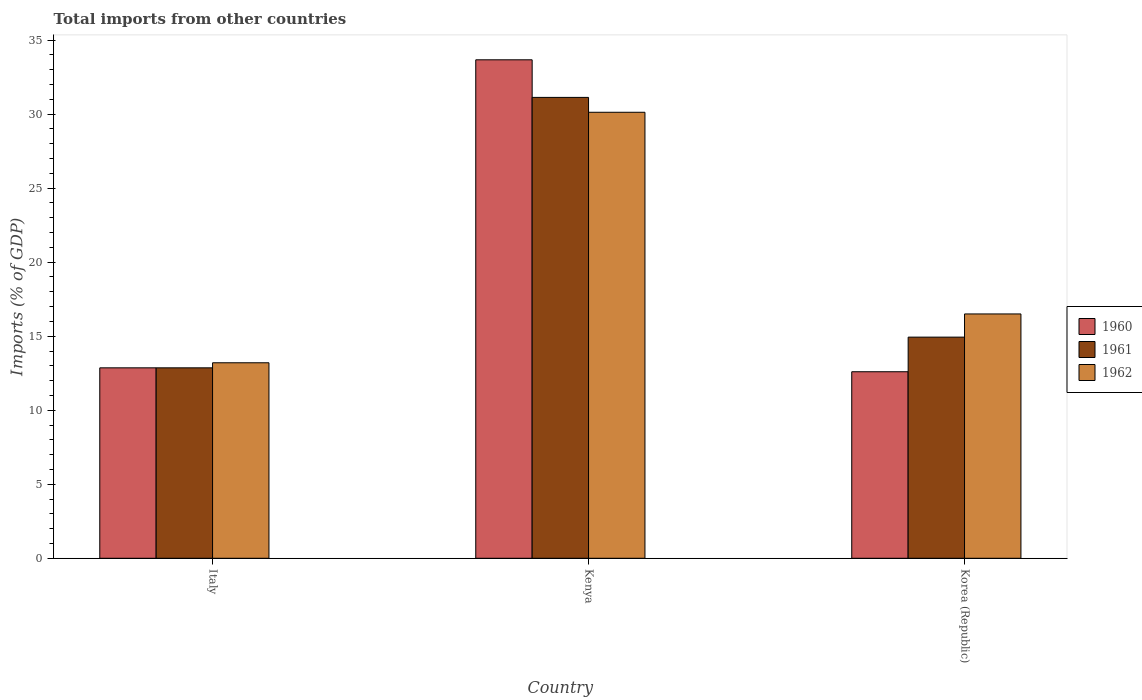How many groups of bars are there?
Give a very brief answer. 3. Are the number of bars on each tick of the X-axis equal?
Ensure brevity in your answer.  Yes. How many bars are there on the 1st tick from the right?
Provide a short and direct response. 3. What is the label of the 2nd group of bars from the left?
Give a very brief answer. Kenya. What is the total imports in 1960 in Italy?
Keep it short and to the point. 12.86. Across all countries, what is the maximum total imports in 1962?
Your answer should be compact. 30.13. Across all countries, what is the minimum total imports in 1961?
Keep it short and to the point. 12.86. In which country was the total imports in 1960 maximum?
Give a very brief answer. Kenya. In which country was the total imports in 1960 minimum?
Your response must be concise. Korea (Republic). What is the total total imports in 1961 in the graph?
Offer a terse response. 58.93. What is the difference between the total imports in 1961 in Italy and that in Korea (Republic)?
Offer a terse response. -2.07. What is the difference between the total imports in 1962 in Kenya and the total imports in 1960 in Italy?
Make the answer very short. 17.26. What is the average total imports in 1962 per country?
Provide a short and direct response. 19.94. What is the difference between the total imports of/in 1961 and total imports of/in 1960 in Kenya?
Keep it short and to the point. -2.54. In how many countries, is the total imports in 1962 greater than 3 %?
Provide a short and direct response. 3. What is the ratio of the total imports in 1961 in Italy to that in Korea (Republic)?
Provide a short and direct response. 0.86. Is the total imports in 1962 in Italy less than that in Korea (Republic)?
Your response must be concise. Yes. What is the difference between the highest and the second highest total imports in 1962?
Provide a succinct answer. 3.3. What is the difference between the highest and the lowest total imports in 1961?
Make the answer very short. 18.27. Is it the case that in every country, the sum of the total imports in 1962 and total imports in 1961 is greater than the total imports in 1960?
Keep it short and to the point. Yes. How many bars are there?
Offer a very short reply. 9. How many countries are there in the graph?
Your response must be concise. 3. What is the difference between two consecutive major ticks on the Y-axis?
Ensure brevity in your answer.  5. Are the values on the major ticks of Y-axis written in scientific E-notation?
Offer a terse response. No. Does the graph contain grids?
Keep it short and to the point. No. Where does the legend appear in the graph?
Your answer should be compact. Center right. How are the legend labels stacked?
Keep it short and to the point. Vertical. What is the title of the graph?
Offer a terse response. Total imports from other countries. Does "1996" appear as one of the legend labels in the graph?
Make the answer very short. No. What is the label or title of the Y-axis?
Provide a succinct answer. Imports (% of GDP). What is the Imports (% of GDP) of 1960 in Italy?
Offer a very short reply. 12.86. What is the Imports (% of GDP) in 1961 in Italy?
Your response must be concise. 12.86. What is the Imports (% of GDP) in 1962 in Italy?
Give a very brief answer. 13.2. What is the Imports (% of GDP) of 1960 in Kenya?
Keep it short and to the point. 33.67. What is the Imports (% of GDP) of 1961 in Kenya?
Provide a short and direct response. 31.13. What is the Imports (% of GDP) in 1962 in Kenya?
Ensure brevity in your answer.  30.13. What is the Imports (% of GDP) of 1960 in Korea (Republic)?
Make the answer very short. 12.6. What is the Imports (% of GDP) in 1961 in Korea (Republic)?
Keep it short and to the point. 14.94. What is the Imports (% of GDP) of 1962 in Korea (Republic)?
Your answer should be compact. 16.5. Across all countries, what is the maximum Imports (% of GDP) of 1960?
Ensure brevity in your answer.  33.67. Across all countries, what is the maximum Imports (% of GDP) of 1961?
Offer a very short reply. 31.13. Across all countries, what is the maximum Imports (% of GDP) in 1962?
Your answer should be compact. 30.13. Across all countries, what is the minimum Imports (% of GDP) of 1960?
Keep it short and to the point. 12.6. Across all countries, what is the minimum Imports (% of GDP) of 1961?
Ensure brevity in your answer.  12.86. Across all countries, what is the minimum Imports (% of GDP) in 1962?
Give a very brief answer. 13.2. What is the total Imports (% of GDP) of 1960 in the graph?
Provide a short and direct response. 59.13. What is the total Imports (% of GDP) of 1961 in the graph?
Provide a short and direct response. 58.93. What is the total Imports (% of GDP) of 1962 in the graph?
Your answer should be compact. 59.83. What is the difference between the Imports (% of GDP) of 1960 in Italy and that in Kenya?
Offer a very short reply. -20.81. What is the difference between the Imports (% of GDP) in 1961 in Italy and that in Kenya?
Your answer should be compact. -18.27. What is the difference between the Imports (% of GDP) of 1962 in Italy and that in Kenya?
Ensure brevity in your answer.  -16.92. What is the difference between the Imports (% of GDP) in 1960 in Italy and that in Korea (Republic)?
Provide a succinct answer. 0.26. What is the difference between the Imports (% of GDP) of 1961 in Italy and that in Korea (Republic)?
Ensure brevity in your answer.  -2.07. What is the difference between the Imports (% of GDP) of 1962 in Italy and that in Korea (Republic)?
Give a very brief answer. -3.3. What is the difference between the Imports (% of GDP) of 1960 in Kenya and that in Korea (Republic)?
Ensure brevity in your answer.  21.07. What is the difference between the Imports (% of GDP) in 1961 in Kenya and that in Korea (Republic)?
Your response must be concise. 16.19. What is the difference between the Imports (% of GDP) of 1962 in Kenya and that in Korea (Republic)?
Provide a short and direct response. 13.62. What is the difference between the Imports (% of GDP) in 1960 in Italy and the Imports (% of GDP) in 1961 in Kenya?
Offer a terse response. -18.27. What is the difference between the Imports (% of GDP) in 1960 in Italy and the Imports (% of GDP) in 1962 in Kenya?
Your answer should be very brief. -17.26. What is the difference between the Imports (% of GDP) of 1961 in Italy and the Imports (% of GDP) of 1962 in Kenya?
Your response must be concise. -17.26. What is the difference between the Imports (% of GDP) of 1960 in Italy and the Imports (% of GDP) of 1961 in Korea (Republic)?
Keep it short and to the point. -2.07. What is the difference between the Imports (% of GDP) of 1960 in Italy and the Imports (% of GDP) of 1962 in Korea (Republic)?
Your response must be concise. -3.64. What is the difference between the Imports (% of GDP) in 1961 in Italy and the Imports (% of GDP) in 1962 in Korea (Republic)?
Provide a succinct answer. -3.64. What is the difference between the Imports (% of GDP) of 1960 in Kenya and the Imports (% of GDP) of 1961 in Korea (Republic)?
Your response must be concise. 18.73. What is the difference between the Imports (% of GDP) in 1960 in Kenya and the Imports (% of GDP) in 1962 in Korea (Republic)?
Keep it short and to the point. 17.17. What is the difference between the Imports (% of GDP) in 1961 in Kenya and the Imports (% of GDP) in 1962 in Korea (Republic)?
Ensure brevity in your answer.  14.63. What is the average Imports (% of GDP) of 1960 per country?
Your response must be concise. 19.71. What is the average Imports (% of GDP) in 1961 per country?
Ensure brevity in your answer.  19.64. What is the average Imports (% of GDP) of 1962 per country?
Offer a very short reply. 19.94. What is the difference between the Imports (% of GDP) in 1960 and Imports (% of GDP) in 1962 in Italy?
Your answer should be compact. -0.34. What is the difference between the Imports (% of GDP) in 1961 and Imports (% of GDP) in 1962 in Italy?
Offer a terse response. -0.34. What is the difference between the Imports (% of GDP) in 1960 and Imports (% of GDP) in 1961 in Kenya?
Keep it short and to the point. 2.54. What is the difference between the Imports (% of GDP) of 1960 and Imports (% of GDP) of 1962 in Kenya?
Your response must be concise. 3.54. What is the difference between the Imports (% of GDP) in 1961 and Imports (% of GDP) in 1962 in Kenya?
Make the answer very short. 1. What is the difference between the Imports (% of GDP) of 1960 and Imports (% of GDP) of 1961 in Korea (Republic)?
Offer a terse response. -2.34. What is the difference between the Imports (% of GDP) of 1960 and Imports (% of GDP) of 1962 in Korea (Republic)?
Offer a terse response. -3.9. What is the difference between the Imports (% of GDP) of 1961 and Imports (% of GDP) of 1962 in Korea (Republic)?
Your response must be concise. -1.57. What is the ratio of the Imports (% of GDP) in 1960 in Italy to that in Kenya?
Offer a very short reply. 0.38. What is the ratio of the Imports (% of GDP) in 1961 in Italy to that in Kenya?
Your response must be concise. 0.41. What is the ratio of the Imports (% of GDP) in 1962 in Italy to that in Kenya?
Your answer should be very brief. 0.44. What is the ratio of the Imports (% of GDP) in 1960 in Italy to that in Korea (Republic)?
Offer a terse response. 1.02. What is the ratio of the Imports (% of GDP) in 1961 in Italy to that in Korea (Republic)?
Give a very brief answer. 0.86. What is the ratio of the Imports (% of GDP) of 1962 in Italy to that in Korea (Republic)?
Make the answer very short. 0.8. What is the ratio of the Imports (% of GDP) of 1960 in Kenya to that in Korea (Republic)?
Ensure brevity in your answer.  2.67. What is the ratio of the Imports (% of GDP) of 1961 in Kenya to that in Korea (Republic)?
Provide a succinct answer. 2.08. What is the ratio of the Imports (% of GDP) in 1962 in Kenya to that in Korea (Republic)?
Provide a succinct answer. 1.83. What is the difference between the highest and the second highest Imports (% of GDP) of 1960?
Ensure brevity in your answer.  20.81. What is the difference between the highest and the second highest Imports (% of GDP) in 1961?
Offer a terse response. 16.19. What is the difference between the highest and the second highest Imports (% of GDP) in 1962?
Keep it short and to the point. 13.62. What is the difference between the highest and the lowest Imports (% of GDP) in 1960?
Make the answer very short. 21.07. What is the difference between the highest and the lowest Imports (% of GDP) in 1961?
Make the answer very short. 18.27. What is the difference between the highest and the lowest Imports (% of GDP) of 1962?
Offer a terse response. 16.92. 